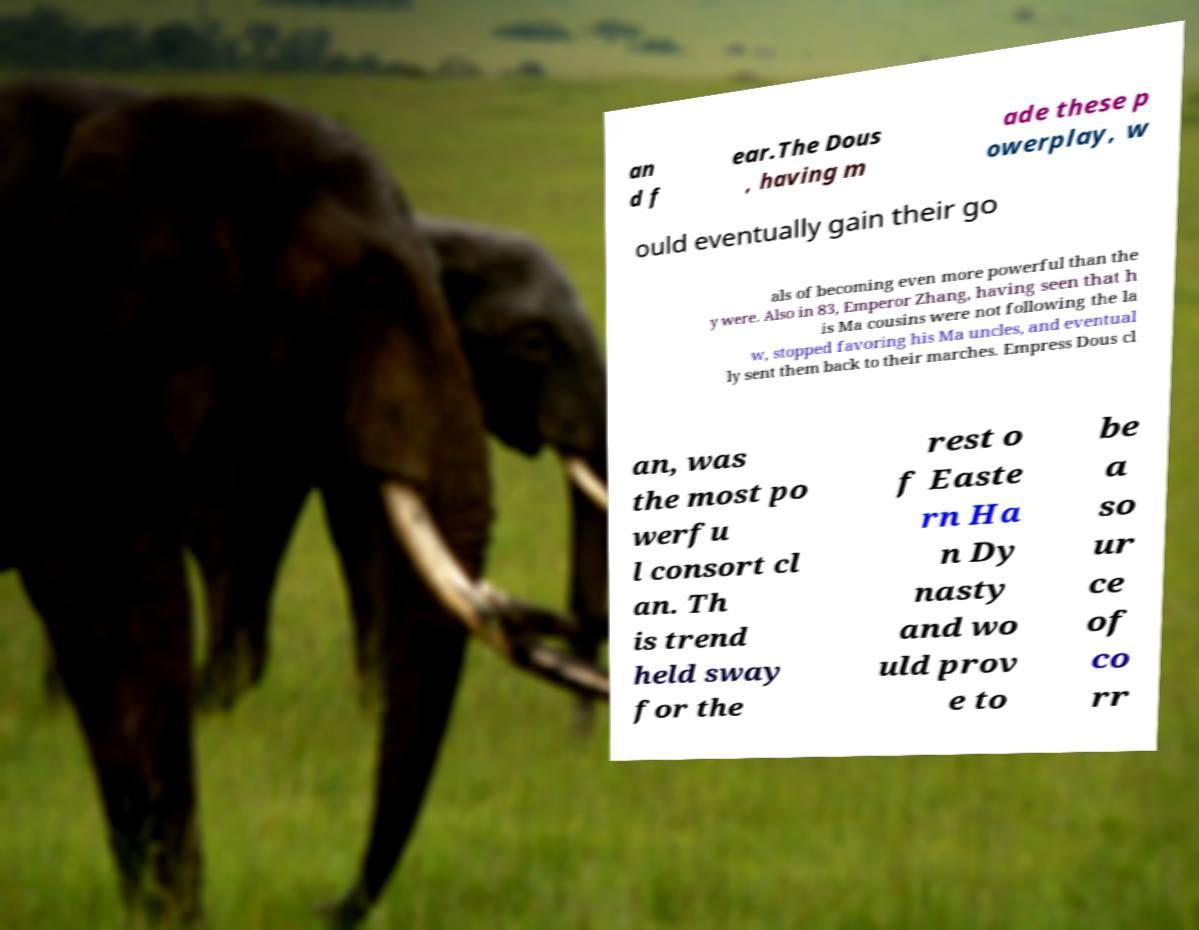There's text embedded in this image that I need extracted. Can you transcribe it verbatim? an d f ear.The Dous , having m ade these p owerplay, w ould eventually gain their go als of becoming even more powerful than the y were. Also in 83, Emperor Zhang, having seen that h is Ma cousins were not following the la w, stopped favoring his Ma uncles, and eventual ly sent them back to their marches. Empress Dous cl an, was the most po werfu l consort cl an. Th is trend held sway for the rest o f Easte rn Ha n Dy nasty and wo uld prov e to be a so ur ce of co rr 